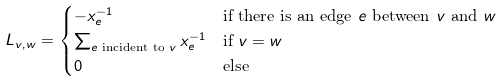Convert formula to latex. <formula><loc_0><loc_0><loc_500><loc_500>L _ { v , w } & = \begin{cases} - x _ { e } ^ { - 1 } & \text {if there is an edge $e$ between $v$ and $w$} \\ \sum _ { e \text { incident to } v } x _ { e } ^ { - 1 } & \text {if $v=w$ } \\ 0 & \text {else} \end{cases}</formula> 